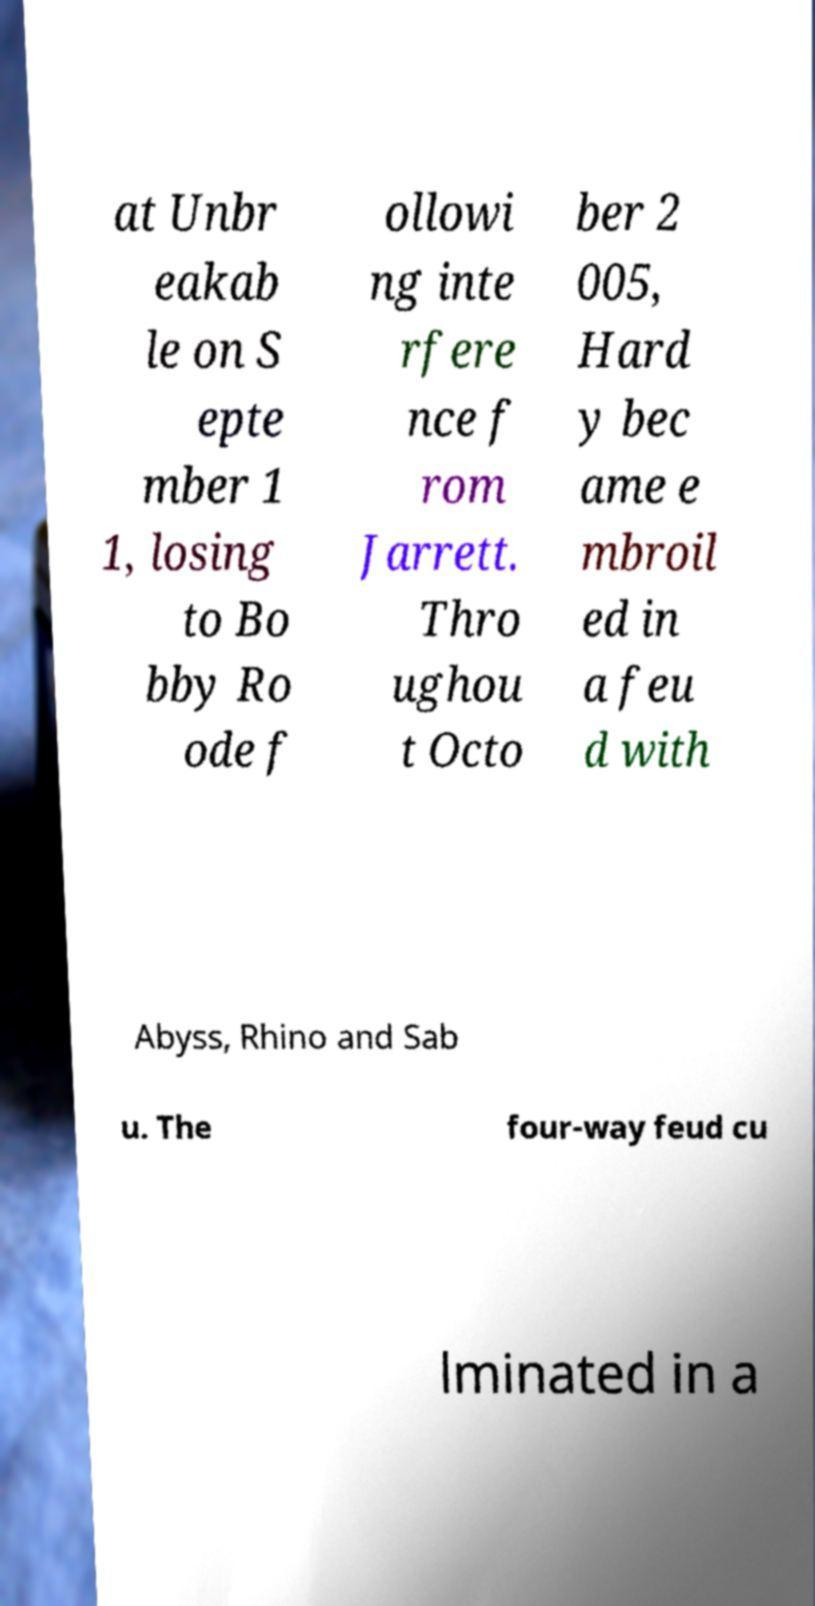Please read and relay the text visible in this image. What does it say? at Unbr eakab le on S epte mber 1 1, losing to Bo bby Ro ode f ollowi ng inte rfere nce f rom Jarrett. Thro ughou t Octo ber 2 005, Hard y bec ame e mbroil ed in a feu d with Abyss, Rhino and Sab u. The four-way feud cu lminated in a 